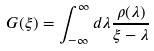Convert formula to latex. <formula><loc_0><loc_0><loc_500><loc_500>G ( \xi ) = \int _ { - \infty } ^ { \infty } d \lambda \frac { \rho ( \lambda ) } { \xi - \lambda }</formula> 